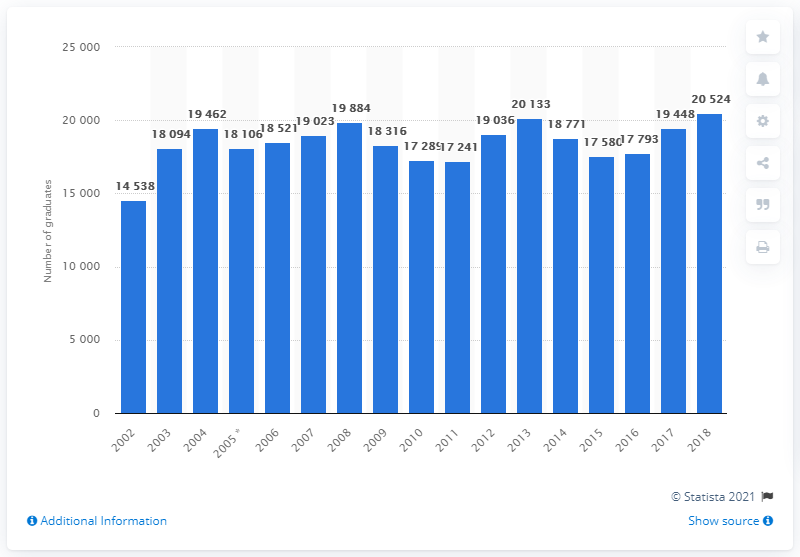Mention a couple of crucial points in this snapshot. In 2018, a total of 20524 students graduated with a nursing degree in the United Kingdom. 